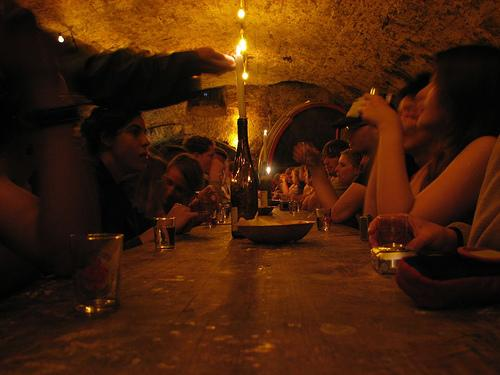What is the name for this style of table? banquet 